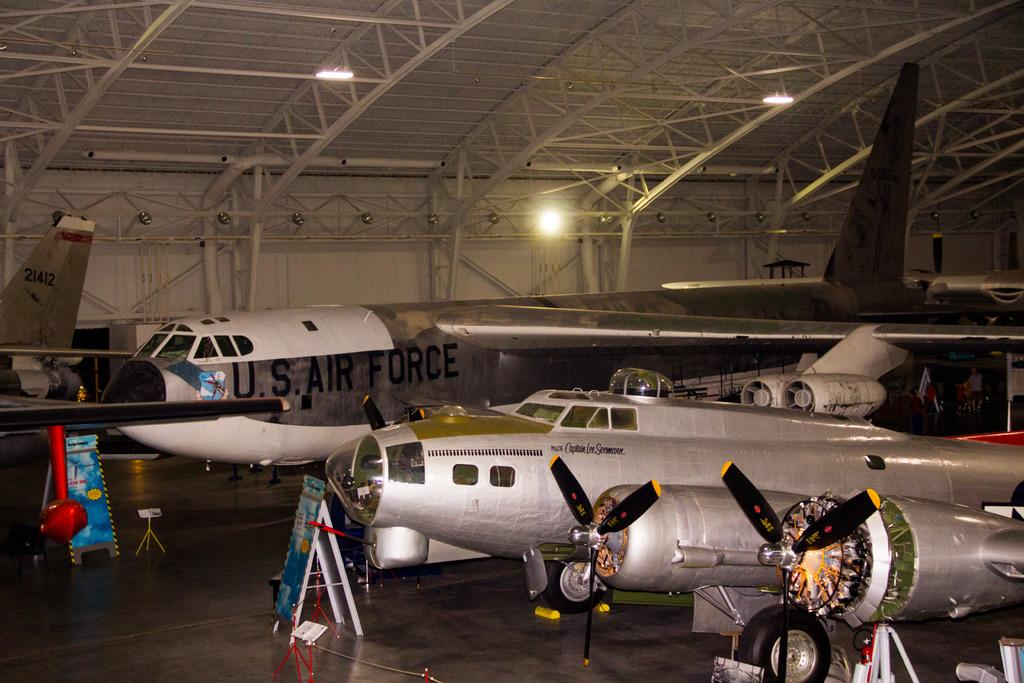<image>
Summarize the visual content of the image. An indoor hangar has large planes in it and the biggest one says U.S. Air Force. 